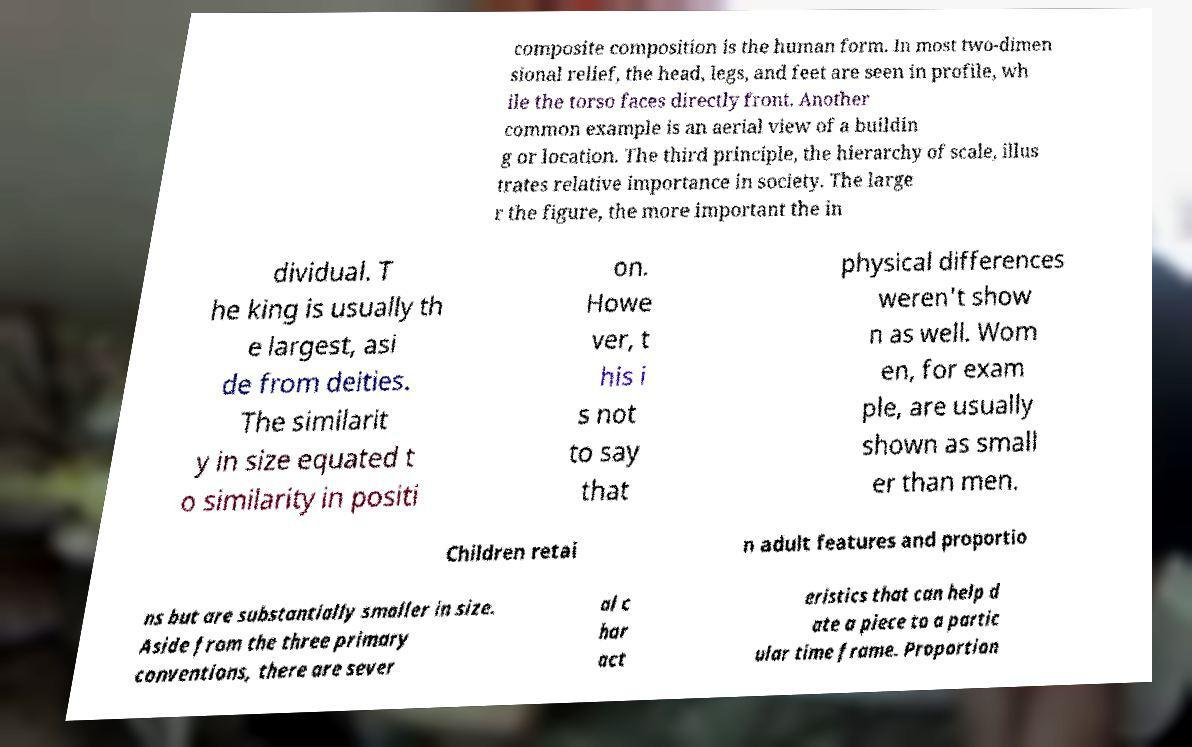Can you accurately transcribe the text from the provided image for me? composite composition is the human form. In most two-dimen sional relief, the head, legs, and feet are seen in profile, wh ile the torso faces directly front. Another common example is an aerial view of a buildin g or location. The third principle, the hierarchy of scale, illus trates relative importance in society. The large r the figure, the more important the in dividual. T he king is usually th e largest, asi de from deities. The similarit y in size equated t o similarity in positi on. Howe ver, t his i s not to say that physical differences weren't show n as well. Wom en, for exam ple, are usually shown as small er than men. Children retai n adult features and proportio ns but are substantially smaller in size. Aside from the three primary conventions, there are sever al c har act eristics that can help d ate a piece to a partic ular time frame. Proportion 